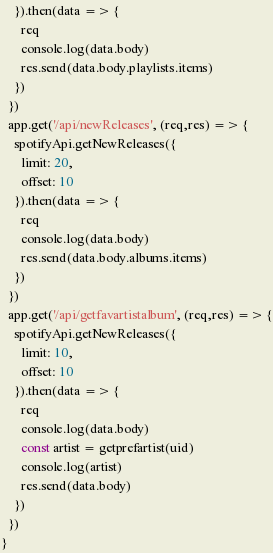Convert code to text. <code><loc_0><loc_0><loc_500><loc_500><_TypeScript_>    }).then(data => {
      req
      console.log(data.body)
      res.send(data.body.playlists.items)
    })
  })
  app.get('/api/newReleases', (req,res) => {
    spotifyApi.getNewReleases({
      limit: 20,
      offset: 10
    }).then(data => {
      req
      console.log(data.body)
      res.send(data.body.albums.items)
    })
  })
  app.get('/api/getfavartistalbum', (req,res) => {
    spotifyApi.getNewReleases({
      limit: 10,
      offset: 10
    }).then(data => {
      req
      console.log(data.body)
      const artist = getprefartist(uid)
      console.log(artist)
      res.send(data.body)
    })
  })
}


</code> 